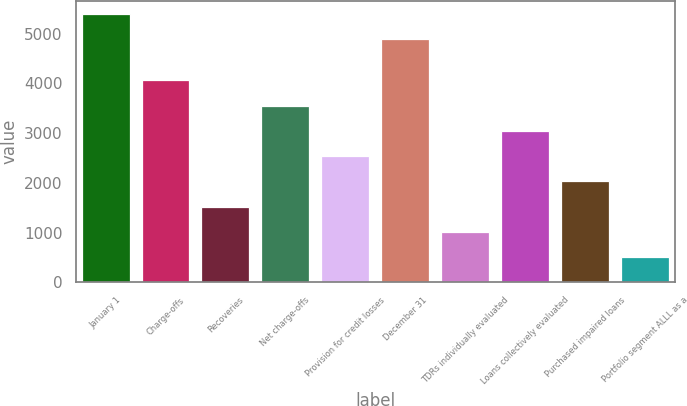Convert chart. <chart><loc_0><loc_0><loc_500><loc_500><bar_chart><fcel>January 1<fcel>Charge-offs<fcel>Recoveries<fcel>Net charge-offs<fcel>Provision for credit losses<fcel>December 31<fcel>TDRs individually evaluated<fcel>Loans collectively evaluated<fcel>Purchased impaired loans<fcel>Portfolio segment ALLL as a<nl><fcel>5393.88<fcel>4058.26<fcel>1523.88<fcel>3551.39<fcel>2537.64<fcel>4887<fcel>1017<fcel>3044.51<fcel>2030.76<fcel>510.12<nl></chart> 